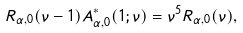Convert formula to latex. <formula><loc_0><loc_0><loc_500><loc_500>R _ { \alpha , 0 } ( \nu - 1 ) A _ { \alpha , 0 } ^ { \ast } ( 1 ; \nu ) = \nu ^ { 5 } R _ { \alpha , 0 } ( \nu ) ,</formula> 